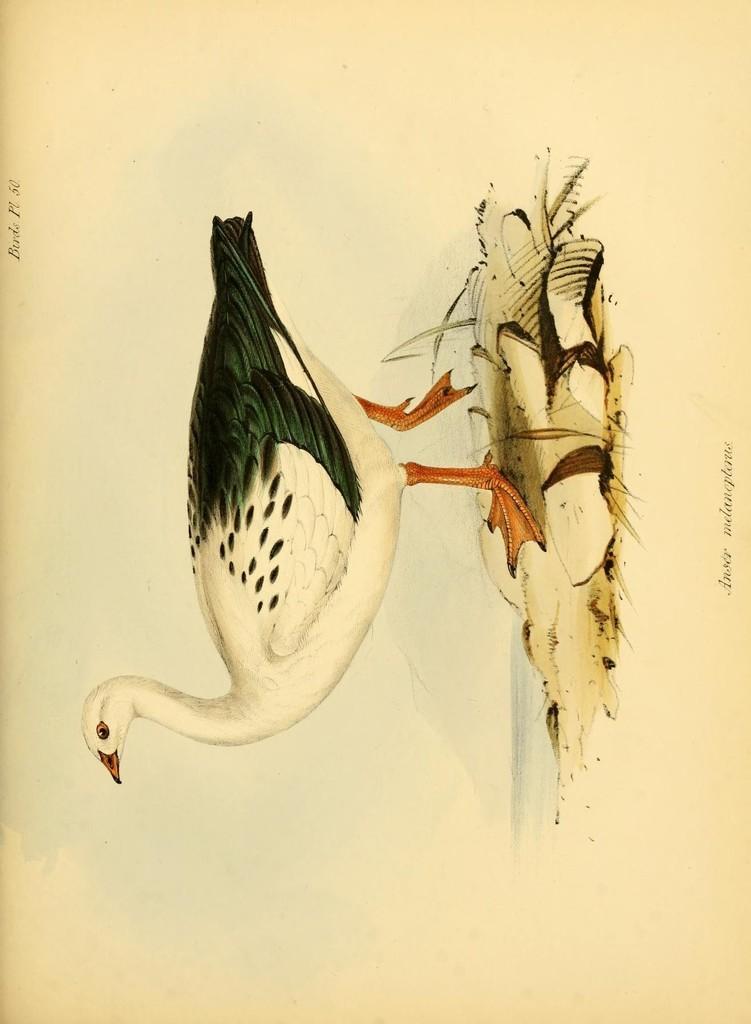Describe this image in one or two sentences. In the image we can see a paper, on the paper there is drawing. 